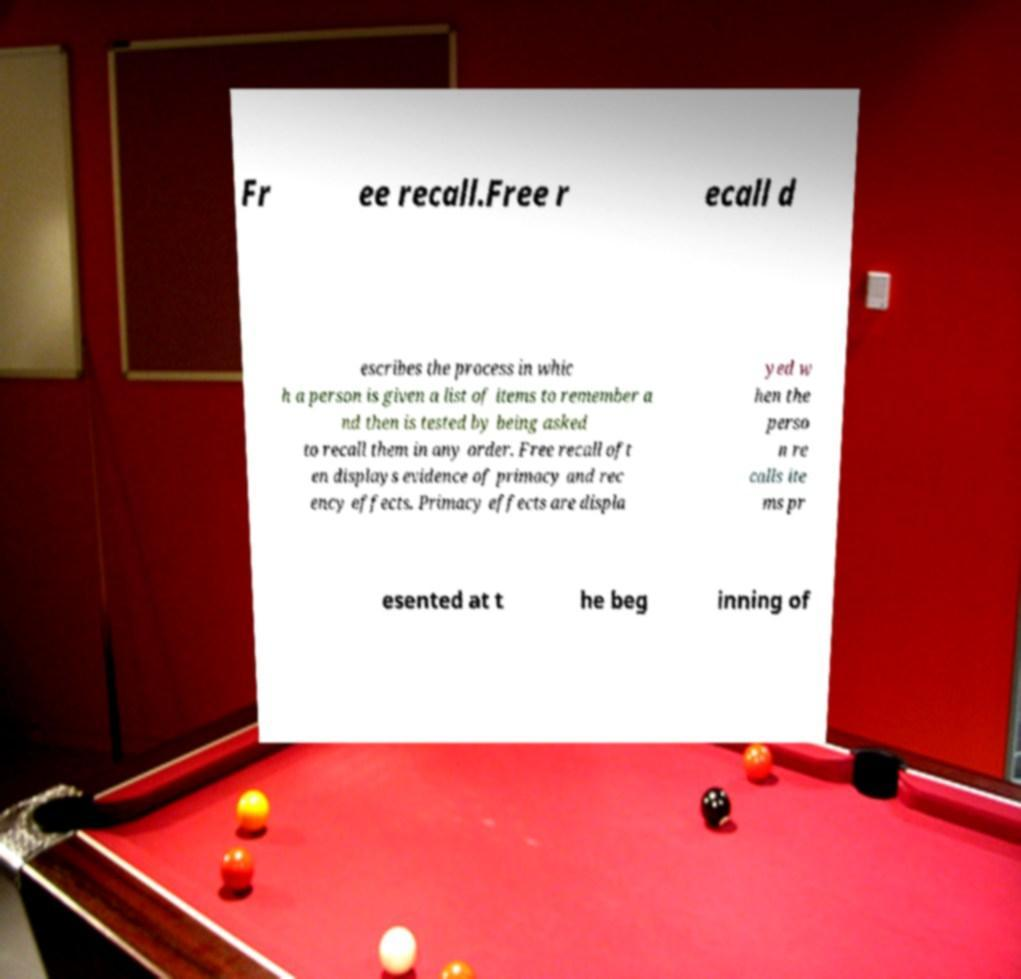There's text embedded in this image that I need extracted. Can you transcribe it verbatim? Fr ee recall.Free r ecall d escribes the process in whic h a person is given a list of items to remember a nd then is tested by being asked to recall them in any order. Free recall oft en displays evidence of primacy and rec ency effects. Primacy effects are displa yed w hen the perso n re calls ite ms pr esented at t he beg inning of 